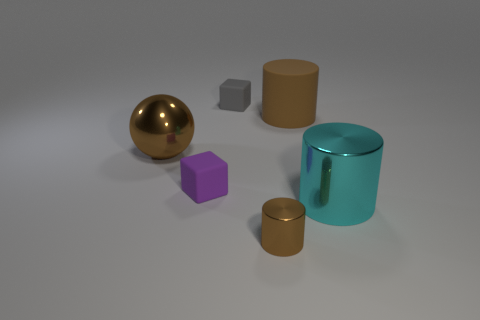There is a large shiny object right of the big brown rubber cylinder; what shape is it?
Ensure brevity in your answer.  Cylinder. Do the large metallic object that is in front of the tiny purple object and the big brown rubber object have the same shape?
Your answer should be compact. Yes. How many objects are metal things left of the small brown object or large cyan matte cylinders?
Provide a short and direct response. 1. What is the color of the other object that is the same shape as the gray object?
Your response must be concise. Purple. Is there anything else that has the same color as the small cylinder?
Your answer should be very brief. Yes. How big is the brown cylinder on the right side of the small brown cylinder?
Offer a terse response. Large. Is the color of the big metal ball the same as the metallic thing that is on the right side of the small brown cylinder?
Your response must be concise. No. What number of other objects are there of the same material as the large brown sphere?
Your answer should be compact. 2. Are there more red metal spheres than large brown cylinders?
Ensure brevity in your answer.  No. Does the block that is behind the big brown shiny thing have the same color as the large matte thing?
Offer a very short reply. No. 